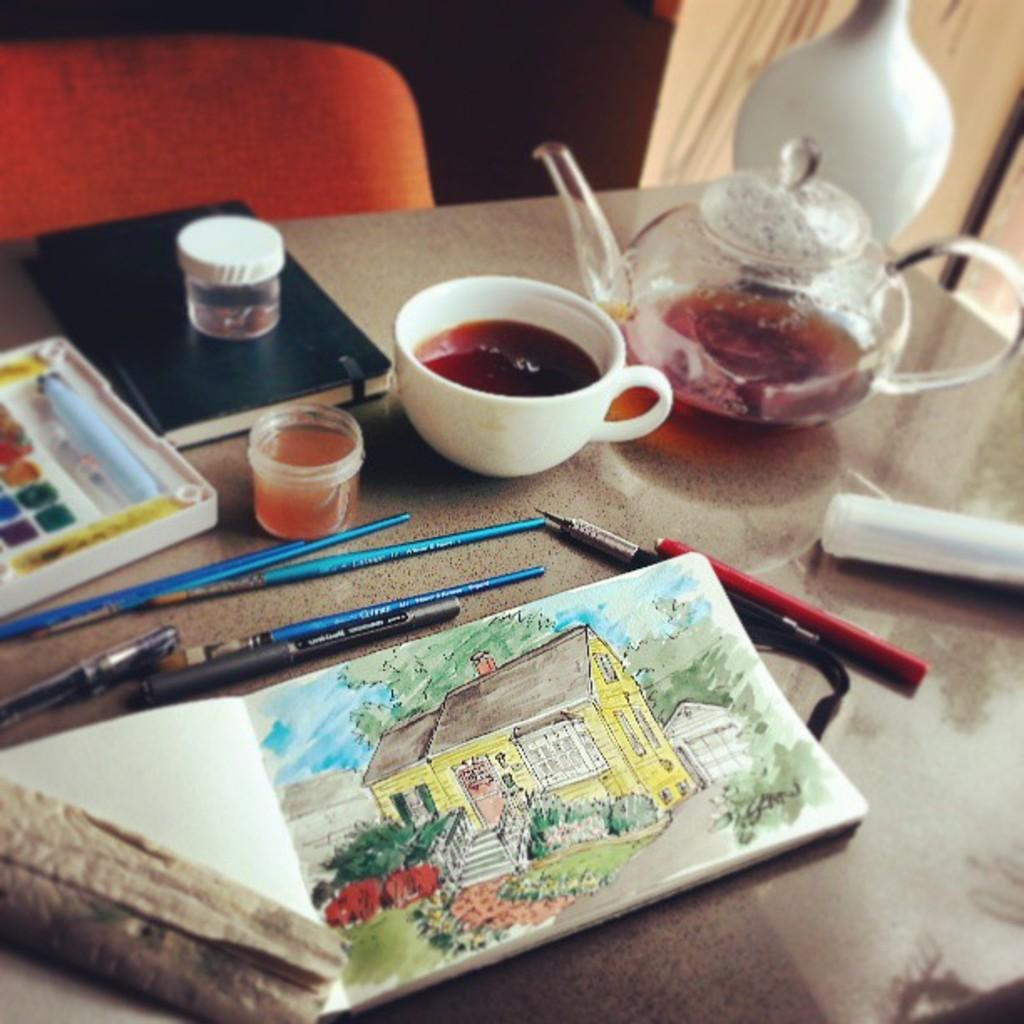What piece of furniture is present in the image? There is a table in the image. What is placed on the table? There is a book, pencils, pens, a cup, a kettle, a paintbox, another book, and other unspecified objects on the table. Can you describe the writing instruments on the table? Yes, there are pencils and pens on the table. What type of beverage container is on the table? There is a cup on the table. What is the other kitchen appliance on the table? There is a kettle on the table. What type of door is visible in the image? There is no door present in the image; it only features a table with various objects on it. What role does the governor play in the image? There is no governor mentioned or depicted in the image. 